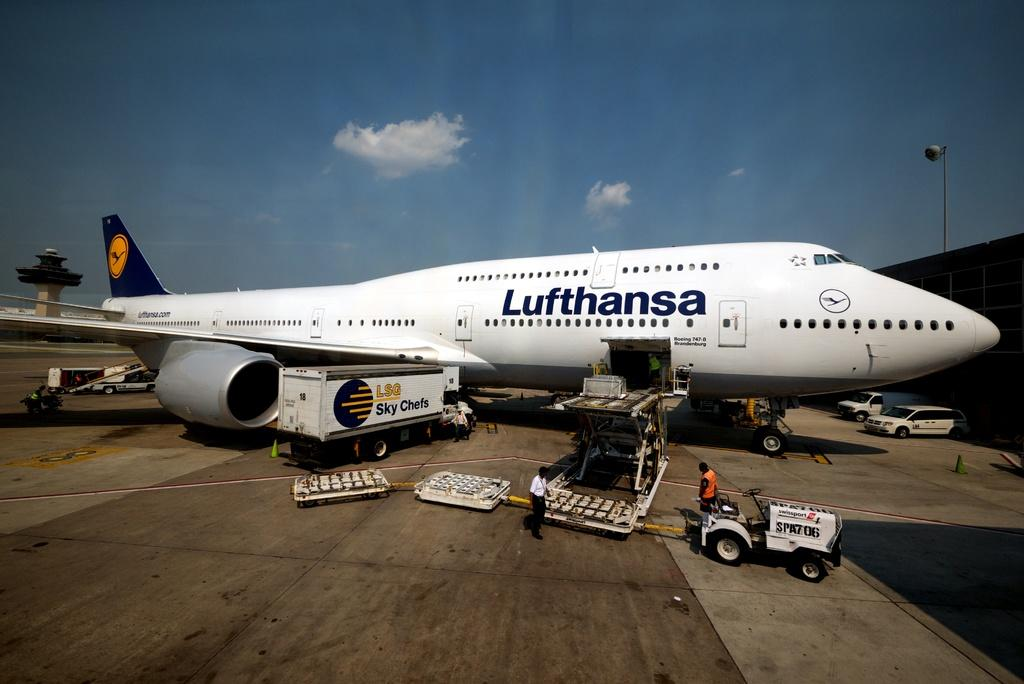Provide a one-sentence caption for the provided image. lufthansa jet being loaded by lsg sky chefs and baggage handlers. 